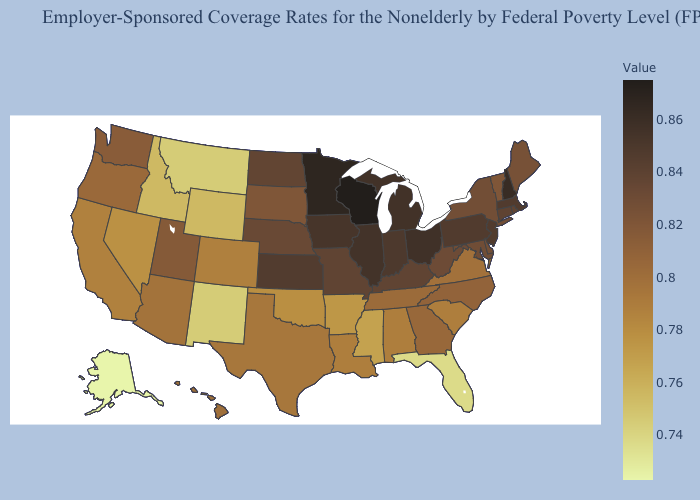Does Indiana have the highest value in the USA?
Be succinct. No. Does the map have missing data?
Keep it brief. No. Does Georgia have a lower value than Delaware?
Give a very brief answer. Yes. Does Mississippi have a higher value than Florida?
Answer briefly. Yes. Among the states that border Oregon , does Washington have the highest value?
Quick response, please. Yes. Does Kansas have a higher value than Nevada?
Short answer required. Yes. 